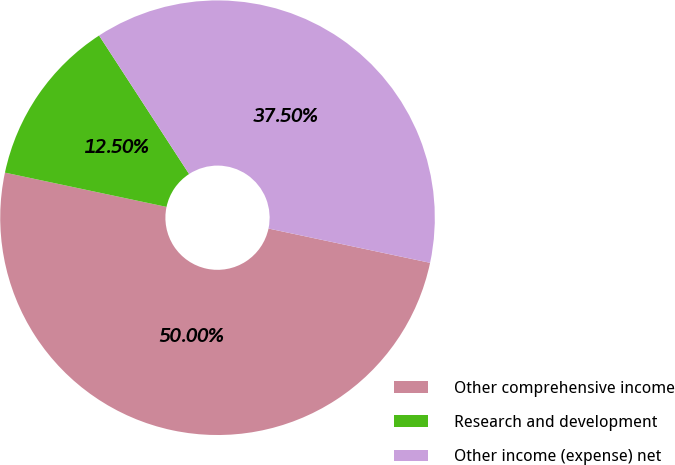<chart> <loc_0><loc_0><loc_500><loc_500><pie_chart><fcel>Other comprehensive income<fcel>Research and development<fcel>Other income (expense) net<nl><fcel>50.0%<fcel>12.5%<fcel>37.5%<nl></chart> 